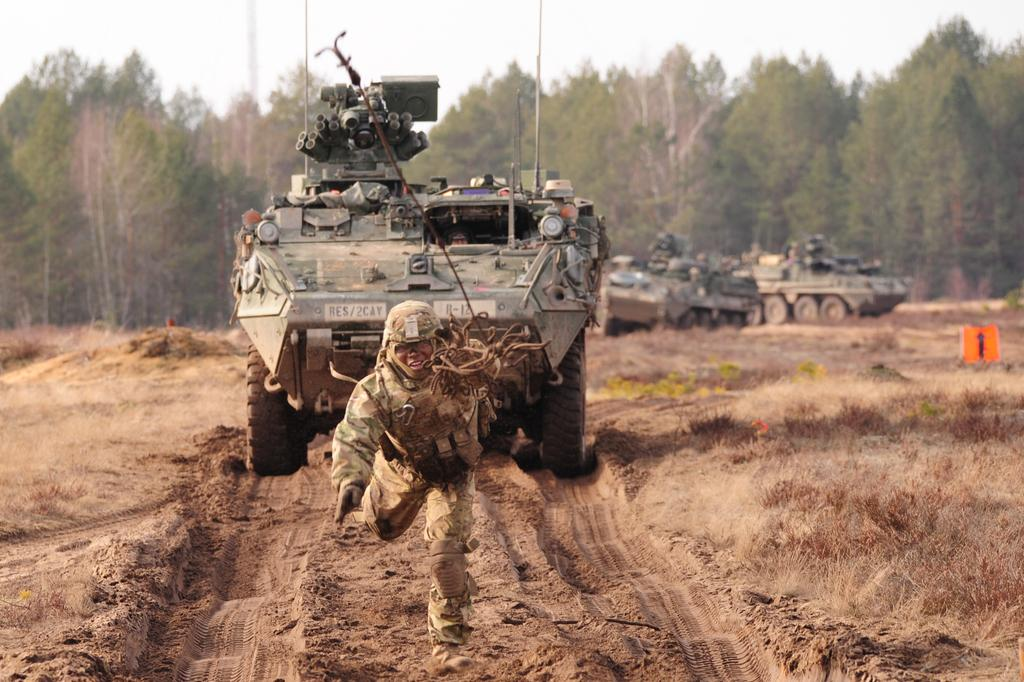What is the man in the image doing? The man is running in the image. What is located behind the man? There is a military vehicle behind the man. What can be seen at the bottom of the image? The ground is visible at the bottom of the image. What type of natural environment is visible in the background? There are many trees in the background of the image. How many lizards can be seen climbing on the sink in the image? There are no lizards or sinks present in the image. 